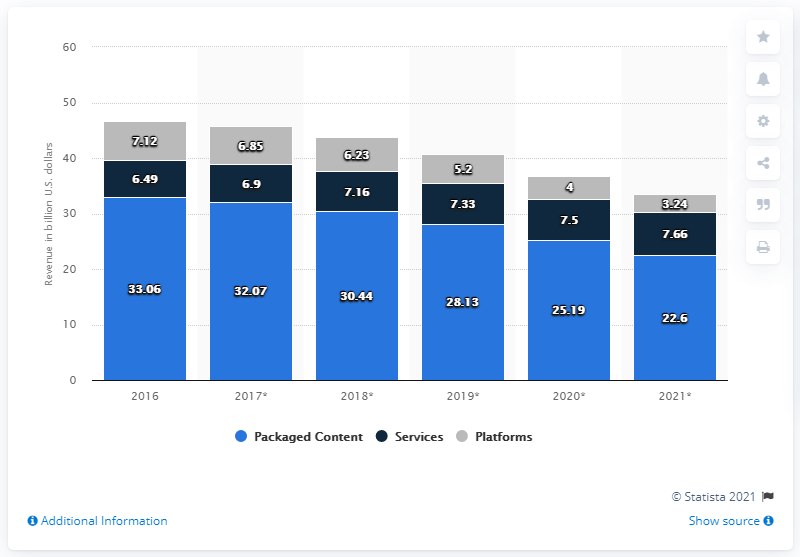Highlight a few significant elements in this photo. In 2016, packaged retail self-paced content generated a total revenue of 33.06. According to projections, the revenue of packaged retail self-paced content is expected to reach 22.6 billion by 2021. 